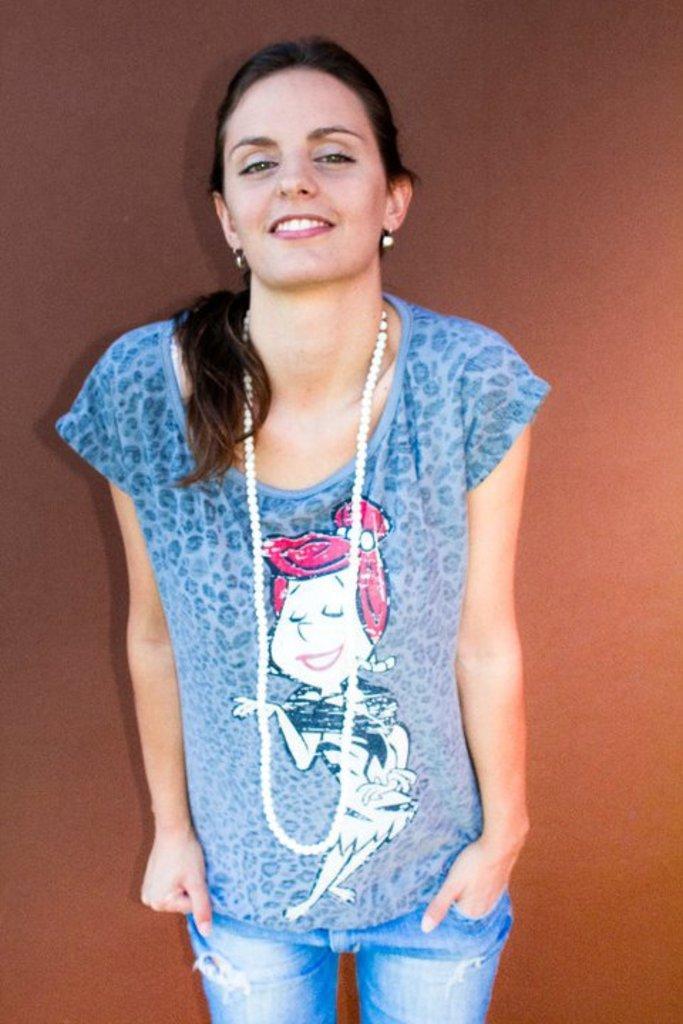Can you describe this image briefly? In this picture I can see a woman standing and smiling, behind the woman there is a light brown background. 